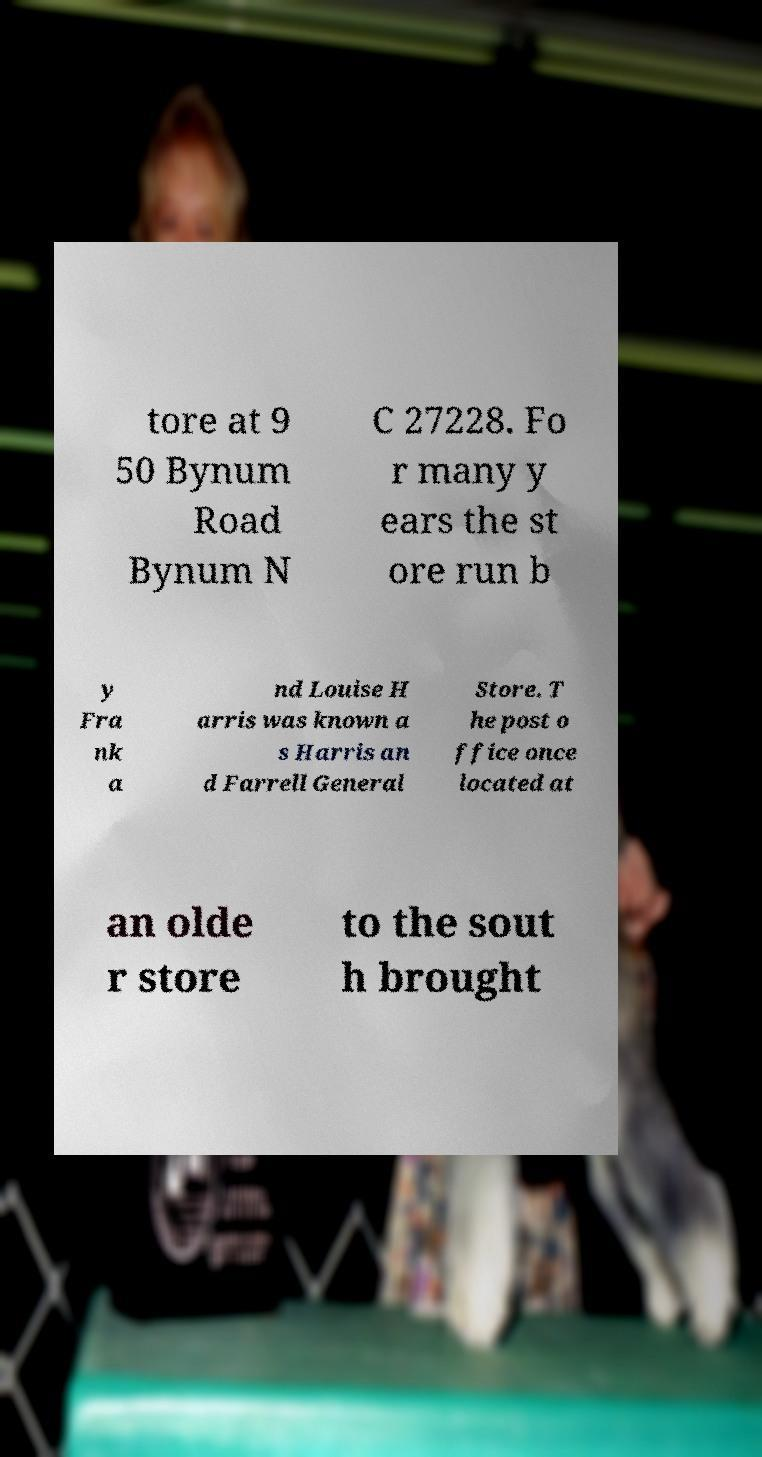Could you assist in decoding the text presented in this image and type it out clearly? tore at 9 50 Bynum Road Bynum N C 27228. Fo r many y ears the st ore run b y Fra nk a nd Louise H arris was known a s Harris an d Farrell General Store. T he post o ffice once located at an olde r store to the sout h brought 